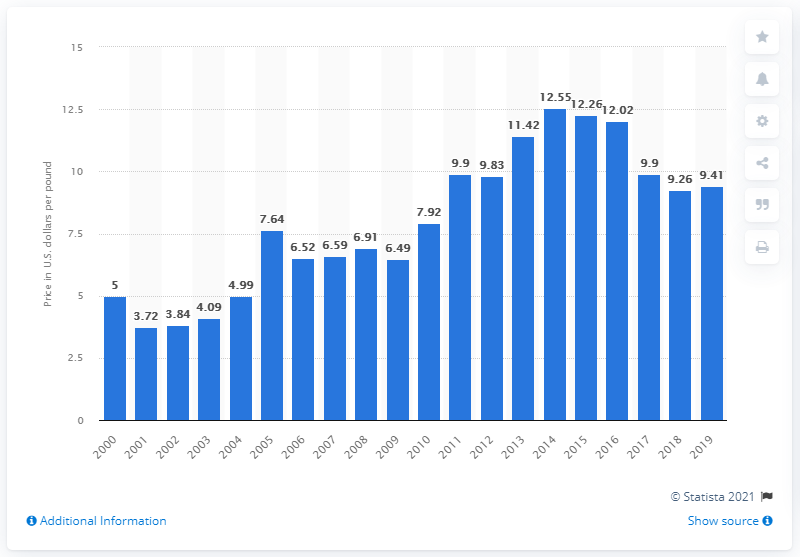Outline some significant characteristics in this image. In 2019, the average price of sea scallops in the United States was 9.41 dollars per pound. 